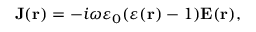Convert formula to latex. <formula><loc_0><loc_0><loc_500><loc_500>{ J } ( { r } ) = - i \omega \varepsilon _ { 0 } ( \varepsilon ( { r } ) - 1 ) { E } ( { r } ) ,</formula> 